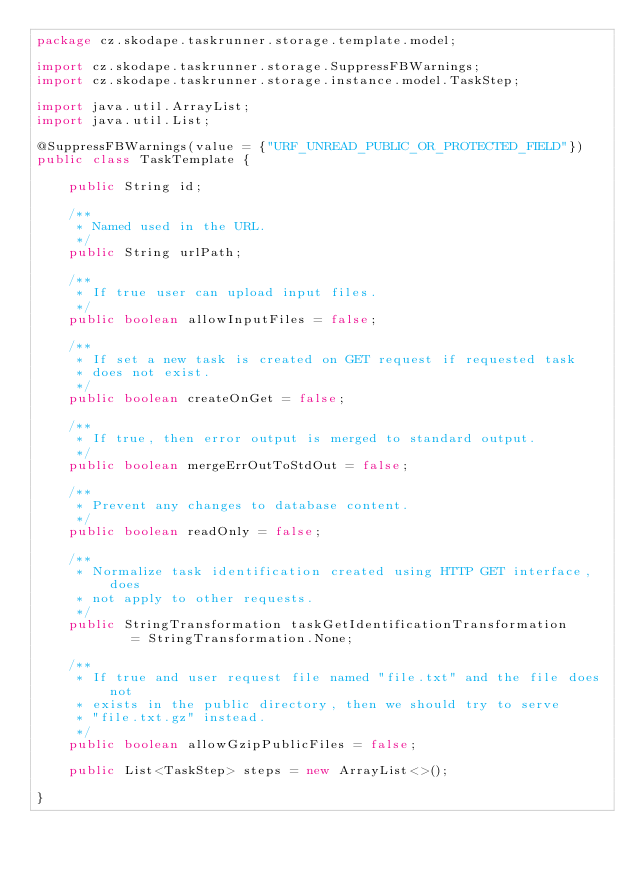<code> <loc_0><loc_0><loc_500><loc_500><_Java_>package cz.skodape.taskrunner.storage.template.model;

import cz.skodape.taskrunner.storage.SuppressFBWarnings;
import cz.skodape.taskrunner.storage.instance.model.TaskStep;

import java.util.ArrayList;
import java.util.List;

@SuppressFBWarnings(value = {"URF_UNREAD_PUBLIC_OR_PROTECTED_FIELD"})
public class TaskTemplate {

    public String id;

    /**
     * Named used in the URL.
     */
    public String urlPath;

    /**
     * If true user can upload input files.
     */
    public boolean allowInputFiles = false;

    /**
     * If set a new task is created on GET request if requested task
     * does not exist.
     */
    public boolean createOnGet = false;

    /**
     * If true, then error output is merged to standard output.
     */
    public boolean mergeErrOutToStdOut = false;

    /**
     * Prevent any changes to database content.
     */
    public boolean readOnly = false;

    /**
     * Normalize task identification created using HTTP GET interface, does
     * not apply to other requests.
     */
    public StringTransformation taskGetIdentificationTransformation
            = StringTransformation.None;

    /**
     * If true and user request file named "file.txt" and the file does not
     * exists in the public directory, then we should try to serve
     * "file.txt.gz" instead.
     */
    public boolean allowGzipPublicFiles = false;

    public List<TaskStep> steps = new ArrayList<>();

}
</code> 